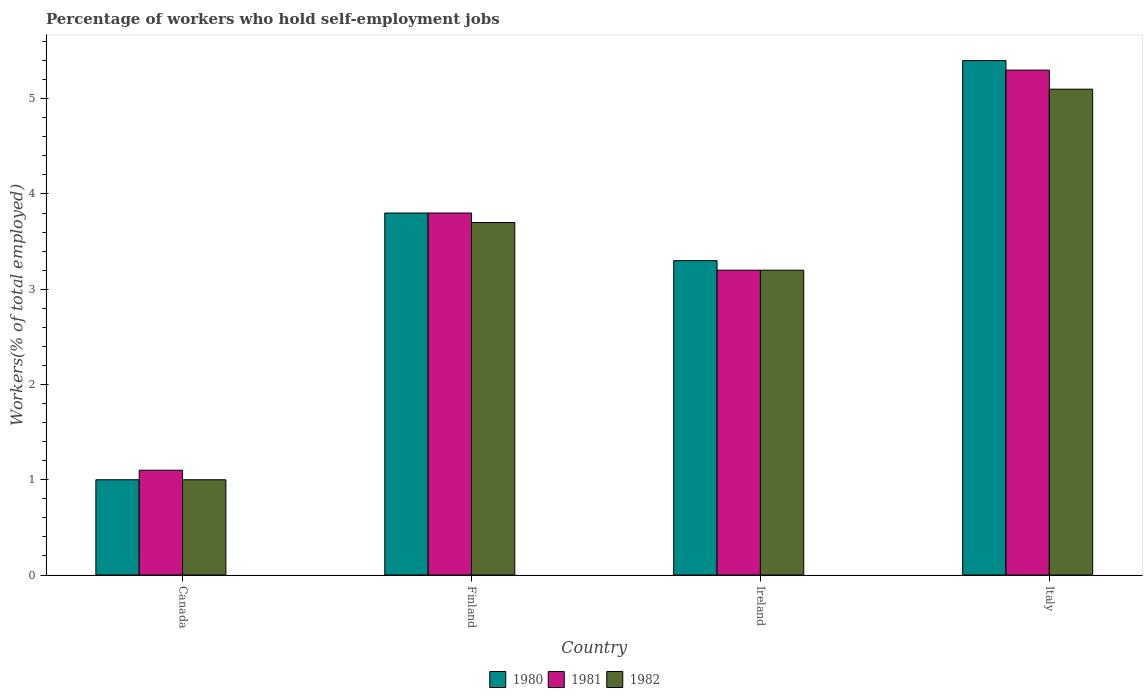How many different coloured bars are there?
Offer a very short reply. 3. Are the number of bars per tick equal to the number of legend labels?
Keep it short and to the point. Yes. How many bars are there on the 3rd tick from the right?
Provide a succinct answer. 3. What is the label of the 3rd group of bars from the left?
Your answer should be very brief. Ireland. In how many cases, is the number of bars for a given country not equal to the number of legend labels?
Give a very brief answer. 0. What is the percentage of self-employed workers in 1981 in Italy?
Offer a very short reply. 5.3. Across all countries, what is the maximum percentage of self-employed workers in 1981?
Offer a terse response. 5.3. Across all countries, what is the minimum percentage of self-employed workers in 1982?
Your answer should be very brief. 1. In which country was the percentage of self-employed workers in 1981 maximum?
Your answer should be very brief. Italy. In which country was the percentage of self-employed workers in 1980 minimum?
Your response must be concise. Canada. What is the total percentage of self-employed workers in 1981 in the graph?
Give a very brief answer. 13.4. What is the difference between the percentage of self-employed workers in 1981 in Ireland and that in Italy?
Ensure brevity in your answer.  -2.1. What is the difference between the percentage of self-employed workers in 1980 in Canada and the percentage of self-employed workers in 1982 in Ireland?
Make the answer very short. -2.2. What is the average percentage of self-employed workers in 1982 per country?
Provide a succinct answer. 3.25. What is the difference between the percentage of self-employed workers of/in 1982 and percentage of self-employed workers of/in 1981 in Italy?
Keep it short and to the point. -0.2. In how many countries, is the percentage of self-employed workers in 1982 greater than 3.4 %?
Offer a terse response. 2. What is the ratio of the percentage of self-employed workers in 1982 in Finland to that in Ireland?
Ensure brevity in your answer.  1.16. Is the percentage of self-employed workers in 1982 in Canada less than that in Italy?
Offer a very short reply. Yes. What is the difference between the highest and the lowest percentage of self-employed workers in 1982?
Provide a short and direct response. 4.1. In how many countries, is the percentage of self-employed workers in 1981 greater than the average percentage of self-employed workers in 1981 taken over all countries?
Provide a short and direct response. 2. What does the 3rd bar from the left in Italy represents?
Ensure brevity in your answer.  1982. What does the 3rd bar from the right in Italy represents?
Provide a succinct answer. 1980. How many bars are there?
Provide a succinct answer. 12. How many countries are there in the graph?
Make the answer very short. 4. What is the difference between two consecutive major ticks on the Y-axis?
Provide a succinct answer. 1. How many legend labels are there?
Your answer should be compact. 3. How are the legend labels stacked?
Your answer should be compact. Horizontal. What is the title of the graph?
Your answer should be compact. Percentage of workers who hold self-employment jobs. What is the label or title of the X-axis?
Offer a terse response. Country. What is the label or title of the Y-axis?
Your answer should be compact. Workers(% of total employed). What is the Workers(% of total employed) of 1980 in Canada?
Ensure brevity in your answer.  1. What is the Workers(% of total employed) of 1981 in Canada?
Make the answer very short. 1.1. What is the Workers(% of total employed) of 1982 in Canada?
Make the answer very short. 1. What is the Workers(% of total employed) in 1980 in Finland?
Your answer should be compact. 3.8. What is the Workers(% of total employed) of 1981 in Finland?
Offer a very short reply. 3.8. What is the Workers(% of total employed) of 1982 in Finland?
Give a very brief answer. 3.7. What is the Workers(% of total employed) in 1980 in Ireland?
Keep it short and to the point. 3.3. What is the Workers(% of total employed) of 1981 in Ireland?
Your answer should be compact. 3.2. What is the Workers(% of total employed) in 1982 in Ireland?
Your answer should be very brief. 3.2. What is the Workers(% of total employed) in 1980 in Italy?
Offer a terse response. 5.4. What is the Workers(% of total employed) of 1981 in Italy?
Provide a short and direct response. 5.3. What is the Workers(% of total employed) of 1982 in Italy?
Provide a short and direct response. 5.1. Across all countries, what is the maximum Workers(% of total employed) in 1980?
Provide a succinct answer. 5.4. Across all countries, what is the maximum Workers(% of total employed) in 1981?
Your response must be concise. 5.3. Across all countries, what is the maximum Workers(% of total employed) of 1982?
Your answer should be very brief. 5.1. Across all countries, what is the minimum Workers(% of total employed) of 1980?
Your answer should be compact. 1. Across all countries, what is the minimum Workers(% of total employed) of 1981?
Offer a terse response. 1.1. Across all countries, what is the minimum Workers(% of total employed) of 1982?
Ensure brevity in your answer.  1. What is the difference between the Workers(% of total employed) in 1980 in Canada and that in Finland?
Your response must be concise. -2.8. What is the difference between the Workers(% of total employed) in 1980 in Canada and that in Ireland?
Your answer should be very brief. -2.3. What is the difference between the Workers(% of total employed) of 1981 in Canada and that in Ireland?
Ensure brevity in your answer.  -2.1. What is the difference between the Workers(% of total employed) of 1982 in Canada and that in Ireland?
Make the answer very short. -2.2. What is the difference between the Workers(% of total employed) in 1980 in Canada and that in Italy?
Provide a succinct answer. -4.4. What is the difference between the Workers(% of total employed) of 1980 in Ireland and that in Italy?
Your answer should be compact. -2.1. What is the difference between the Workers(% of total employed) of 1981 in Ireland and that in Italy?
Ensure brevity in your answer.  -2.1. What is the difference between the Workers(% of total employed) in 1982 in Ireland and that in Italy?
Make the answer very short. -1.9. What is the difference between the Workers(% of total employed) in 1980 in Canada and the Workers(% of total employed) in 1981 in Finland?
Your response must be concise. -2.8. What is the difference between the Workers(% of total employed) in 1980 in Canada and the Workers(% of total employed) in 1981 in Ireland?
Give a very brief answer. -2.2. What is the difference between the Workers(% of total employed) in 1980 in Canada and the Workers(% of total employed) in 1982 in Ireland?
Keep it short and to the point. -2.2. What is the difference between the Workers(% of total employed) in 1980 in Canada and the Workers(% of total employed) in 1982 in Italy?
Ensure brevity in your answer.  -4.1. What is the difference between the Workers(% of total employed) of 1981 in Canada and the Workers(% of total employed) of 1982 in Italy?
Your answer should be compact. -4. What is the difference between the Workers(% of total employed) of 1980 in Finland and the Workers(% of total employed) of 1982 in Ireland?
Offer a very short reply. 0.6. What is the difference between the Workers(% of total employed) of 1981 in Finland and the Workers(% of total employed) of 1982 in Ireland?
Keep it short and to the point. 0.6. What is the difference between the Workers(% of total employed) of 1980 in Finland and the Workers(% of total employed) of 1981 in Italy?
Your response must be concise. -1.5. What is the difference between the Workers(% of total employed) in 1980 in Finland and the Workers(% of total employed) in 1982 in Italy?
Your answer should be very brief. -1.3. What is the difference between the Workers(% of total employed) of 1980 in Ireland and the Workers(% of total employed) of 1981 in Italy?
Provide a succinct answer. -2. What is the difference between the Workers(% of total employed) of 1980 in Ireland and the Workers(% of total employed) of 1982 in Italy?
Your answer should be very brief. -1.8. What is the difference between the Workers(% of total employed) of 1981 in Ireland and the Workers(% of total employed) of 1982 in Italy?
Make the answer very short. -1.9. What is the average Workers(% of total employed) in 1980 per country?
Your answer should be compact. 3.38. What is the average Workers(% of total employed) of 1981 per country?
Give a very brief answer. 3.35. What is the difference between the Workers(% of total employed) in 1980 and Workers(% of total employed) in 1981 in Canada?
Your answer should be compact. -0.1. What is the difference between the Workers(% of total employed) of 1981 and Workers(% of total employed) of 1982 in Canada?
Make the answer very short. 0.1. What is the difference between the Workers(% of total employed) of 1980 and Workers(% of total employed) of 1982 in Finland?
Keep it short and to the point. 0.1. What is the difference between the Workers(% of total employed) in 1981 and Workers(% of total employed) in 1982 in Finland?
Ensure brevity in your answer.  0.1. What is the difference between the Workers(% of total employed) in 1980 and Workers(% of total employed) in 1981 in Ireland?
Offer a terse response. 0.1. What is the difference between the Workers(% of total employed) of 1980 and Workers(% of total employed) of 1982 in Ireland?
Ensure brevity in your answer.  0.1. What is the difference between the Workers(% of total employed) in 1981 and Workers(% of total employed) in 1982 in Ireland?
Your answer should be very brief. 0. What is the difference between the Workers(% of total employed) in 1981 and Workers(% of total employed) in 1982 in Italy?
Your answer should be very brief. 0.2. What is the ratio of the Workers(% of total employed) of 1980 in Canada to that in Finland?
Offer a terse response. 0.26. What is the ratio of the Workers(% of total employed) of 1981 in Canada to that in Finland?
Your answer should be very brief. 0.29. What is the ratio of the Workers(% of total employed) in 1982 in Canada to that in Finland?
Provide a succinct answer. 0.27. What is the ratio of the Workers(% of total employed) of 1980 in Canada to that in Ireland?
Offer a very short reply. 0.3. What is the ratio of the Workers(% of total employed) of 1981 in Canada to that in Ireland?
Your answer should be very brief. 0.34. What is the ratio of the Workers(% of total employed) of 1982 in Canada to that in Ireland?
Your answer should be very brief. 0.31. What is the ratio of the Workers(% of total employed) in 1980 in Canada to that in Italy?
Offer a terse response. 0.19. What is the ratio of the Workers(% of total employed) in 1981 in Canada to that in Italy?
Your response must be concise. 0.21. What is the ratio of the Workers(% of total employed) in 1982 in Canada to that in Italy?
Provide a short and direct response. 0.2. What is the ratio of the Workers(% of total employed) of 1980 in Finland to that in Ireland?
Keep it short and to the point. 1.15. What is the ratio of the Workers(% of total employed) in 1981 in Finland to that in Ireland?
Provide a short and direct response. 1.19. What is the ratio of the Workers(% of total employed) of 1982 in Finland to that in Ireland?
Make the answer very short. 1.16. What is the ratio of the Workers(% of total employed) of 1980 in Finland to that in Italy?
Give a very brief answer. 0.7. What is the ratio of the Workers(% of total employed) of 1981 in Finland to that in Italy?
Your answer should be very brief. 0.72. What is the ratio of the Workers(% of total employed) in 1982 in Finland to that in Italy?
Offer a terse response. 0.73. What is the ratio of the Workers(% of total employed) in 1980 in Ireland to that in Italy?
Provide a succinct answer. 0.61. What is the ratio of the Workers(% of total employed) of 1981 in Ireland to that in Italy?
Give a very brief answer. 0.6. What is the ratio of the Workers(% of total employed) of 1982 in Ireland to that in Italy?
Give a very brief answer. 0.63. What is the difference between the highest and the second highest Workers(% of total employed) of 1980?
Your answer should be compact. 1.6. What is the difference between the highest and the lowest Workers(% of total employed) in 1981?
Give a very brief answer. 4.2. 